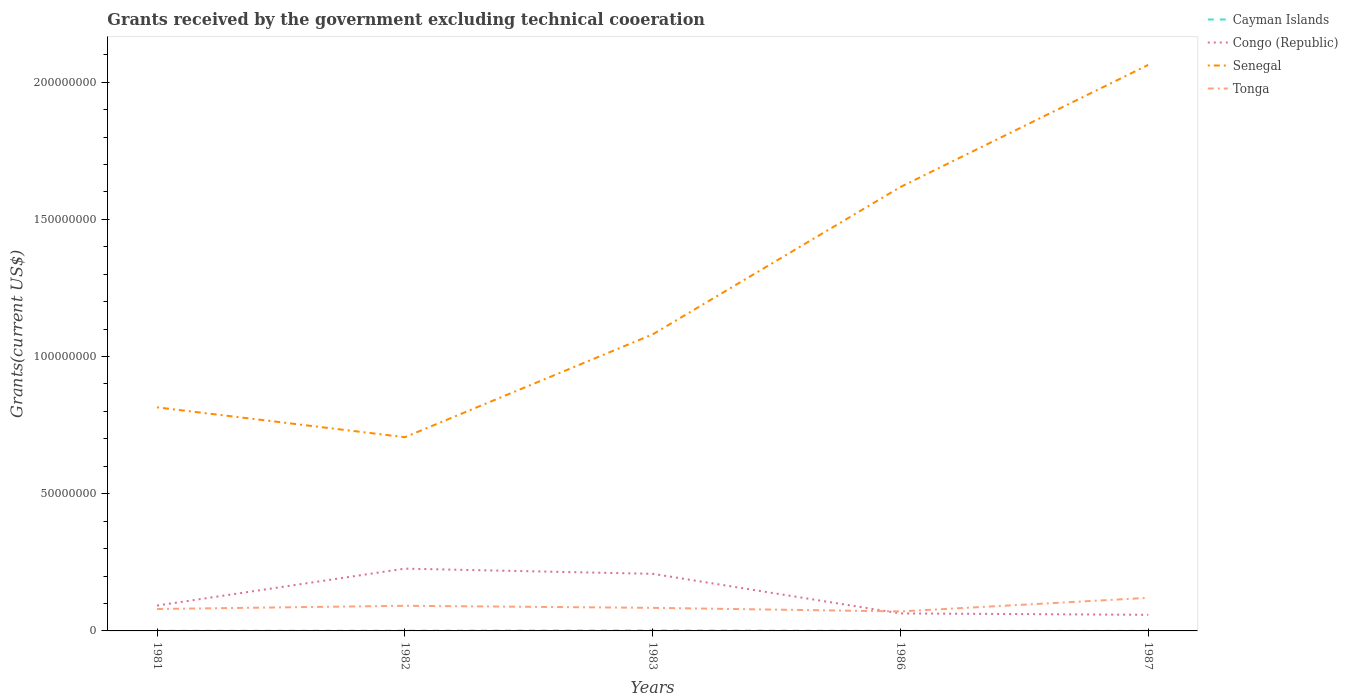How many different coloured lines are there?
Provide a short and direct response. 4. Does the line corresponding to Senegal intersect with the line corresponding to Congo (Republic)?
Offer a terse response. No. Across all years, what is the maximum total grants received by the government in Senegal?
Your answer should be compact. 7.06e+07. What is the total total grants received by the government in Cayman Islands in the graph?
Your response must be concise. 10000. What is the difference between the highest and the second highest total grants received by the government in Tonga?
Your answer should be very brief. 4.96e+06. How many lines are there?
Offer a very short reply. 4. How many years are there in the graph?
Ensure brevity in your answer.  5. What is the difference between two consecutive major ticks on the Y-axis?
Your response must be concise. 5.00e+07. Does the graph contain any zero values?
Keep it short and to the point. No. Does the graph contain grids?
Offer a very short reply. No. Where does the legend appear in the graph?
Provide a succinct answer. Top right. What is the title of the graph?
Give a very brief answer. Grants received by the government excluding technical cooeration. Does "Myanmar" appear as one of the legend labels in the graph?
Offer a terse response. No. What is the label or title of the Y-axis?
Keep it short and to the point. Grants(current US$). What is the Grants(current US$) of Cayman Islands in 1981?
Ensure brevity in your answer.  4.00e+04. What is the Grants(current US$) in Congo (Republic) in 1981?
Provide a succinct answer. 9.25e+06. What is the Grants(current US$) in Senegal in 1981?
Provide a short and direct response. 8.15e+07. What is the Grants(current US$) of Tonga in 1981?
Make the answer very short. 7.99e+06. What is the Grants(current US$) in Cayman Islands in 1982?
Offer a very short reply. 8.00e+04. What is the Grants(current US$) of Congo (Republic) in 1982?
Offer a very short reply. 2.27e+07. What is the Grants(current US$) in Senegal in 1982?
Provide a succinct answer. 7.06e+07. What is the Grants(current US$) of Tonga in 1982?
Ensure brevity in your answer.  9.16e+06. What is the Grants(current US$) in Cayman Islands in 1983?
Make the answer very short. 1.50e+05. What is the Grants(current US$) in Congo (Republic) in 1983?
Give a very brief answer. 2.08e+07. What is the Grants(current US$) of Senegal in 1983?
Your response must be concise. 1.08e+08. What is the Grants(current US$) in Tonga in 1983?
Give a very brief answer. 8.41e+06. What is the Grants(current US$) in Congo (Republic) in 1986?
Ensure brevity in your answer.  6.38e+06. What is the Grants(current US$) in Senegal in 1986?
Offer a terse response. 1.62e+08. What is the Grants(current US$) of Tonga in 1986?
Provide a short and direct response. 7.10e+06. What is the Grants(current US$) in Cayman Islands in 1987?
Your response must be concise. 3.00e+04. What is the Grants(current US$) in Congo (Republic) in 1987?
Ensure brevity in your answer.  5.87e+06. What is the Grants(current US$) in Senegal in 1987?
Provide a short and direct response. 2.06e+08. What is the Grants(current US$) in Tonga in 1987?
Your response must be concise. 1.21e+07. Across all years, what is the maximum Grants(current US$) in Congo (Republic)?
Offer a very short reply. 2.27e+07. Across all years, what is the maximum Grants(current US$) in Senegal?
Your answer should be very brief. 2.06e+08. Across all years, what is the maximum Grants(current US$) in Tonga?
Your answer should be very brief. 1.21e+07. Across all years, what is the minimum Grants(current US$) in Cayman Islands?
Your answer should be compact. 3.00e+04. Across all years, what is the minimum Grants(current US$) of Congo (Republic)?
Keep it short and to the point. 5.87e+06. Across all years, what is the minimum Grants(current US$) in Senegal?
Your answer should be compact. 7.06e+07. Across all years, what is the minimum Grants(current US$) of Tonga?
Provide a succinct answer. 7.10e+06. What is the total Grants(current US$) of Congo (Republic) in the graph?
Make the answer very short. 6.50e+07. What is the total Grants(current US$) of Senegal in the graph?
Provide a short and direct response. 6.28e+08. What is the total Grants(current US$) of Tonga in the graph?
Your response must be concise. 4.47e+07. What is the difference between the Grants(current US$) of Congo (Republic) in 1981 and that in 1982?
Your response must be concise. -1.34e+07. What is the difference between the Grants(current US$) in Senegal in 1981 and that in 1982?
Your answer should be very brief. 1.09e+07. What is the difference between the Grants(current US$) in Tonga in 1981 and that in 1982?
Your answer should be very brief. -1.17e+06. What is the difference between the Grants(current US$) of Congo (Republic) in 1981 and that in 1983?
Make the answer very short. -1.16e+07. What is the difference between the Grants(current US$) of Senegal in 1981 and that in 1983?
Provide a succinct answer. -2.66e+07. What is the difference between the Grants(current US$) in Tonga in 1981 and that in 1983?
Your answer should be compact. -4.20e+05. What is the difference between the Grants(current US$) of Cayman Islands in 1981 and that in 1986?
Your answer should be very brief. 10000. What is the difference between the Grants(current US$) of Congo (Republic) in 1981 and that in 1986?
Offer a terse response. 2.87e+06. What is the difference between the Grants(current US$) in Senegal in 1981 and that in 1986?
Make the answer very short. -8.03e+07. What is the difference between the Grants(current US$) of Tonga in 1981 and that in 1986?
Offer a very short reply. 8.90e+05. What is the difference between the Grants(current US$) of Congo (Republic) in 1981 and that in 1987?
Your answer should be very brief. 3.38e+06. What is the difference between the Grants(current US$) of Senegal in 1981 and that in 1987?
Provide a short and direct response. -1.25e+08. What is the difference between the Grants(current US$) of Tonga in 1981 and that in 1987?
Provide a short and direct response. -4.07e+06. What is the difference between the Grants(current US$) in Cayman Islands in 1982 and that in 1983?
Offer a terse response. -7.00e+04. What is the difference between the Grants(current US$) in Congo (Republic) in 1982 and that in 1983?
Provide a short and direct response. 1.89e+06. What is the difference between the Grants(current US$) in Senegal in 1982 and that in 1983?
Your answer should be compact. -3.75e+07. What is the difference between the Grants(current US$) in Tonga in 1982 and that in 1983?
Ensure brevity in your answer.  7.50e+05. What is the difference between the Grants(current US$) in Congo (Republic) in 1982 and that in 1986?
Make the answer very short. 1.63e+07. What is the difference between the Grants(current US$) of Senegal in 1982 and that in 1986?
Provide a short and direct response. -9.12e+07. What is the difference between the Grants(current US$) of Tonga in 1982 and that in 1986?
Provide a succinct answer. 2.06e+06. What is the difference between the Grants(current US$) in Cayman Islands in 1982 and that in 1987?
Provide a succinct answer. 5.00e+04. What is the difference between the Grants(current US$) in Congo (Republic) in 1982 and that in 1987?
Offer a very short reply. 1.68e+07. What is the difference between the Grants(current US$) of Senegal in 1982 and that in 1987?
Provide a succinct answer. -1.36e+08. What is the difference between the Grants(current US$) in Tonga in 1982 and that in 1987?
Your answer should be very brief. -2.90e+06. What is the difference between the Grants(current US$) in Congo (Republic) in 1983 and that in 1986?
Offer a terse response. 1.44e+07. What is the difference between the Grants(current US$) in Senegal in 1983 and that in 1986?
Keep it short and to the point. -5.37e+07. What is the difference between the Grants(current US$) of Tonga in 1983 and that in 1986?
Keep it short and to the point. 1.31e+06. What is the difference between the Grants(current US$) of Cayman Islands in 1983 and that in 1987?
Your response must be concise. 1.20e+05. What is the difference between the Grants(current US$) of Congo (Republic) in 1983 and that in 1987?
Make the answer very short. 1.49e+07. What is the difference between the Grants(current US$) in Senegal in 1983 and that in 1987?
Your response must be concise. -9.82e+07. What is the difference between the Grants(current US$) in Tonga in 1983 and that in 1987?
Provide a short and direct response. -3.65e+06. What is the difference between the Grants(current US$) of Cayman Islands in 1986 and that in 1987?
Offer a very short reply. 0. What is the difference between the Grants(current US$) of Congo (Republic) in 1986 and that in 1987?
Offer a very short reply. 5.10e+05. What is the difference between the Grants(current US$) in Senegal in 1986 and that in 1987?
Your response must be concise. -4.45e+07. What is the difference between the Grants(current US$) in Tonga in 1986 and that in 1987?
Offer a terse response. -4.96e+06. What is the difference between the Grants(current US$) in Cayman Islands in 1981 and the Grants(current US$) in Congo (Republic) in 1982?
Provide a succinct answer. -2.27e+07. What is the difference between the Grants(current US$) in Cayman Islands in 1981 and the Grants(current US$) in Senegal in 1982?
Offer a terse response. -7.06e+07. What is the difference between the Grants(current US$) in Cayman Islands in 1981 and the Grants(current US$) in Tonga in 1982?
Offer a very short reply. -9.12e+06. What is the difference between the Grants(current US$) in Congo (Republic) in 1981 and the Grants(current US$) in Senegal in 1982?
Give a very brief answer. -6.14e+07. What is the difference between the Grants(current US$) of Senegal in 1981 and the Grants(current US$) of Tonga in 1982?
Your answer should be very brief. 7.23e+07. What is the difference between the Grants(current US$) in Cayman Islands in 1981 and the Grants(current US$) in Congo (Republic) in 1983?
Offer a very short reply. -2.08e+07. What is the difference between the Grants(current US$) of Cayman Islands in 1981 and the Grants(current US$) of Senegal in 1983?
Offer a terse response. -1.08e+08. What is the difference between the Grants(current US$) in Cayman Islands in 1981 and the Grants(current US$) in Tonga in 1983?
Offer a terse response. -8.37e+06. What is the difference between the Grants(current US$) in Congo (Republic) in 1981 and the Grants(current US$) in Senegal in 1983?
Ensure brevity in your answer.  -9.88e+07. What is the difference between the Grants(current US$) in Congo (Republic) in 1981 and the Grants(current US$) in Tonga in 1983?
Keep it short and to the point. 8.40e+05. What is the difference between the Grants(current US$) of Senegal in 1981 and the Grants(current US$) of Tonga in 1983?
Your answer should be compact. 7.31e+07. What is the difference between the Grants(current US$) in Cayman Islands in 1981 and the Grants(current US$) in Congo (Republic) in 1986?
Your response must be concise. -6.34e+06. What is the difference between the Grants(current US$) in Cayman Islands in 1981 and the Grants(current US$) in Senegal in 1986?
Provide a succinct answer. -1.62e+08. What is the difference between the Grants(current US$) in Cayman Islands in 1981 and the Grants(current US$) in Tonga in 1986?
Your answer should be very brief. -7.06e+06. What is the difference between the Grants(current US$) in Congo (Republic) in 1981 and the Grants(current US$) in Senegal in 1986?
Ensure brevity in your answer.  -1.53e+08. What is the difference between the Grants(current US$) of Congo (Republic) in 1981 and the Grants(current US$) of Tonga in 1986?
Give a very brief answer. 2.15e+06. What is the difference between the Grants(current US$) of Senegal in 1981 and the Grants(current US$) of Tonga in 1986?
Make the answer very short. 7.44e+07. What is the difference between the Grants(current US$) in Cayman Islands in 1981 and the Grants(current US$) in Congo (Republic) in 1987?
Keep it short and to the point. -5.83e+06. What is the difference between the Grants(current US$) of Cayman Islands in 1981 and the Grants(current US$) of Senegal in 1987?
Ensure brevity in your answer.  -2.06e+08. What is the difference between the Grants(current US$) of Cayman Islands in 1981 and the Grants(current US$) of Tonga in 1987?
Make the answer very short. -1.20e+07. What is the difference between the Grants(current US$) of Congo (Republic) in 1981 and the Grants(current US$) of Senegal in 1987?
Your answer should be very brief. -1.97e+08. What is the difference between the Grants(current US$) of Congo (Republic) in 1981 and the Grants(current US$) of Tonga in 1987?
Keep it short and to the point. -2.81e+06. What is the difference between the Grants(current US$) in Senegal in 1981 and the Grants(current US$) in Tonga in 1987?
Your answer should be very brief. 6.94e+07. What is the difference between the Grants(current US$) of Cayman Islands in 1982 and the Grants(current US$) of Congo (Republic) in 1983?
Offer a very short reply. -2.07e+07. What is the difference between the Grants(current US$) in Cayman Islands in 1982 and the Grants(current US$) in Senegal in 1983?
Ensure brevity in your answer.  -1.08e+08. What is the difference between the Grants(current US$) of Cayman Islands in 1982 and the Grants(current US$) of Tonga in 1983?
Make the answer very short. -8.33e+06. What is the difference between the Grants(current US$) of Congo (Republic) in 1982 and the Grants(current US$) of Senegal in 1983?
Your answer should be compact. -8.54e+07. What is the difference between the Grants(current US$) of Congo (Republic) in 1982 and the Grants(current US$) of Tonga in 1983?
Offer a terse response. 1.43e+07. What is the difference between the Grants(current US$) of Senegal in 1982 and the Grants(current US$) of Tonga in 1983?
Ensure brevity in your answer.  6.22e+07. What is the difference between the Grants(current US$) in Cayman Islands in 1982 and the Grants(current US$) in Congo (Republic) in 1986?
Offer a very short reply. -6.30e+06. What is the difference between the Grants(current US$) of Cayman Islands in 1982 and the Grants(current US$) of Senegal in 1986?
Your answer should be very brief. -1.62e+08. What is the difference between the Grants(current US$) of Cayman Islands in 1982 and the Grants(current US$) of Tonga in 1986?
Provide a short and direct response. -7.02e+06. What is the difference between the Grants(current US$) in Congo (Republic) in 1982 and the Grants(current US$) in Senegal in 1986?
Make the answer very short. -1.39e+08. What is the difference between the Grants(current US$) in Congo (Republic) in 1982 and the Grants(current US$) in Tonga in 1986?
Ensure brevity in your answer.  1.56e+07. What is the difference between the Grants(current US$) in Senegal in 1982 and the Grants(current US$) in Tonga in 1986?
Ensure brevity in your answer.  6.35e+07. What is the difference between the Grants(current US$) in Cayman Islands in 1982 and the Grants(current US$) in Congo (Republic) in 1987?
Provide a succinct answer. -5.79e+06. What is the difference between the Grants(current US$) in Cayman Islands in 1982 and the Grants(current US$) in Senegal in 1987?
Provide a succinct answer. -2.06e+08. What is the difference between the Grants(current US$) in Cayman Islands in 1982 and the Grants(current US$) in Tonga in 1987?
Your answer should be compact. -1.20e+07. What is the difference between the Grants(current US$) of Congo (Republic) in 1982 and the Grants(current US$) of Senegal in 1987?
Offer a terse response. -1.84e+08. What is the difference between the Grants(current US$) of Congo (Republic) in 1982 and the Grants(current US$) of Tonga in 1987?
Your answer should be very brief. 1.06e+07. What is the difference between the Grants(current US$) of Senegal in 1982 and the Grants(current US$) of Tonga in 1987?
Your answer should be compact. 5.85e+07. What is the difference between the Grants(current US$) of Cayman Islands in 1983 and the Grants(current US$) of Congo (Republic) in 1986?
Your answer should be compact. -6.23e+06. What is the difference between the Grants(current US$) of Cayman Islands in 1983 and the Grants(current US$) of Senegal in 1986?
Your answer should be compact. -1.62e+08. What is the difference between the Grants(current US$) of Cayman Islands in 1983 and the Grants(current US$) of Tonga in 1986?
Offer a very short reply. -6.95e+06. What is the difference between the Grants(current US$) in Congo (Republic) in 1983 and the Grants(current US$) in Senegal in 1986?
Make the answer very short. -1.41e+08. What is the difference between the Grants(current US$) of Congo (Republic) in 1983 and the Grants(current US$) of Tonga in 1986?
Your answer should be very brief. 1.37e+07. What is the difference between the Grants(current US$) of Senegal in 1983 and the Grants(current US$) of Tonga in 1986?
Provide a succinct answer. 1.01e+08. What is the difference between the Grants(current US$) of Cayman Islands in 1983 and the Grants(current US$) of Congo (Republic) in 1987?
Give a very brief answer. -5.72e+06. What is the difference between the Grants(current US$) of Cayman Islands in 1983 and the Grants(current US$) of Senegal in 1987?
Make the answer very short. -2.06e+08. What is the difference between the Grants(current US$) in Cayman Islands in 1983 and the Grants(current US$) in Tonga in 1987?
Your answer should be very brief. -1.19e+07. What is the difference between the Grants(current US$) in Congo (Republic) in 1983 and the Grants(current US$) in Senegal in 1987?
Offer a terse response. -1.85e+08. What is the difference between the Grants(current US$) of Congo (Republic) in 1983 and the Grants(current US$) of Tonga in 1987?
Your answer should be compact. 8.75e+06. What is the difference between the Grants(current US$) in Senegal in 1983 and the Grants(current US$) in Tonga in 1987?
Your answer should be compact. 9.60e+07. What is the difference between the Grants(current US$) in Cayman Islands in 1986 and the Grants(current US$) in Congo (Republic) in 1987?
Your answer should be compact. -5.84e+06. What is the difference between the Grants(current US$) of Cayman Islands in 1986 and the Grants(current US$) of Senegal in 1987?
Offer a terse response. -2.06e+08. What is the difference between the Grants(current US$) in Cayman Islands in 1986 and the Grants(current US$) in Tonga in 1987?
Ensure brevity in your answer.  -1.20e+07. What is the difference between the Grants(current US$) of Congo (Republic) in 1986 and the Grants(current US$) of Senegal in 1987?
Offer a terse response. -2.00e+08. What is the difference between the Grants(current US$) in Congo (Republic) in 1986 and the Grants(current US$) in Tonga in 1987?
Provide a succinct answer. -5.68e+06. What is the difference between the Grants(current US$) in Senegal in 1986 and the Grants(current US$) in Tonga in 1987?
Your answer should be very brief. 1.50e+08. What is the average Grants(current US$) in Cayman Islands per year?
Make the answer very short. 6.60e+04. What is the average Grants(current US$) of Congo (Republic) per year?
Keep it short and to the point. 1.30e+07. What is the average Grants(current US$) in Senegal per year?
Keep it short and to the point. 1.26e+08. What is the average Grants(current US$) in Tonga per year?
Offer a terse response. 8.94e+06. In the year 1981, what is the difference between the Grants(current US$) in Cayman Islands and Grants(current US$) in Congo (Republic)?
Provide a short and direct response. -9.21e+06. In the year 1981, what is the difference between the Grants(current US$) in Cayman Islands and Grants(current US$) in Senegal?
Provide a succinct answer. -8.14e+07. In the year 1981, what is the difference between the Grants(current US$) of Cayman Islands and Grants(current US$) of Tonga?
Provide a short and direct response. -7.95e+06. In the year 1981, what is the difference between the Grants(current US$) in Congo (Republic) and Grants(current US$) in Senegal?
Keep it short and to the point. -7.22e+07. In the year 1981, what is the difference between the Grants(current US$) in Congo (Republic) and Grants(current US$) in Tonga?
Keep it short and to the point. 1.26e+06. In the year 1981, what is the difference between the Grants(current US$) in Senegal and Grants(current US$) in Tonga?
Provide a short and direct response. 7.35e+07. In the year 1982, what is the difference between the Grants(current US$) of Cayman Islands and Grants(current US$) of Congo (Republic)?
Your answer should be very brief. -2.26e+07. In the year 1982, what is the difference between the Grants(current US$) in Cayman Islands and Grants(current US$) in Senegal?
Give a very brief answer. -7.05e+07. In the year 1982, what is the difference between the Grants(current US$) in Cayman Islands and Grants(current US$) in Tonga?
Offer a very short reply. -9.08e+06. In the year 1982, what is the difference between the Grants(current US$) in Congo (Republic) and Grants(current US$) in Senegal?
Your response must be concise. -4.79e+07. In the year 1982, what is the difference between the Grants(current US$) in Congo (Republic) and Grants(current US$) in Tonga?
Ensure brevity in your answer.  1.35e+07. In the year 1982, what is the difference between the Grants(current US$) in Senegal and Grants(current US$) in Tonga?
Offer a very short reply. 6.14e+07. In the year 1983, what is the difference between the Grants(current US$) in Cayman Islands and Grants(current US$) in Congo (Republic)?
Ensure brevity in your answer.  -2.07e+07. In the year 1983, what is the difference between the Grants(current US$) in Cayman Islands and Grants(current US$) in Senegal?
Provide a short and direct response. -1.08e+08. In the year 1983, what is the difference between the Grants(current US$) of Cayman Islands and Grants(current US$) of Tonga?
Provide a short and direct response. -8.26e+06. In the year 1983, what is the difference between the Grants(current US$) of Congo (Republic) and Grants(current US$) of Senegal?
Provide a succinct answer. -8.73e+07. In the year 1983, what is the difference between the Grants(current US$) of Congo (Republic) and Grants(current US$) of Tonga?
Offer a terse response. 1.24e+07. In the year 1983, what is the difference between the Grants(current US$) of Senegal and Grants(current US$) of Tonga?
Your answer should be very brief. 9.97e+07. In the year 1986, what is the difference between the Grants(current US$) of Cayman Islands and Grants(current US$) of Congo (Republic)?
Make the answer very short. -6.35e+06. In the year 1986, what is the difference between the Grants(current US$) of Cayman Islands and Grants(current US$) of Senegal?
Provide a succinct answer. -1.62e+08. In the year 1986, what is the difference between the Grants(current US$) in Cayman Islands and Grants(current US$) in Tonga?
Keep it short and to the point. -7.07e+06. In the year 1986, what is the difference between the Grants(current US$) in Congo (Republic) and Grants(current US$) in Senegal?
Your response must be concise. -1.55e+08. In the year 1986, what is the difference between the Grants(current US$) in Congo (Republic) and Grants(current US$) in Tonga?
Offer a terse response. -7.20e+05. In the year 1986, what is the difference between the Grants(current US$) of Senegal and Grants(current US$) of Tonga?
Your answer should be very brief. 1.55e+08. In the year 1987, what is the difference between the Grants(current US$) of Cayman Islands and Grants(current US$) of Congo (Republic)?
Offer a terse response. -5.84e+06. In the year 1987, what is the difference between the Grants(current US$) of Cayman Islands and Grants(current US$) of Senegal?
Ensure brevity in your answer.  -2.06e+08. In the year 1987, what is the difference between the Grants(current US$) in Cayman Islands and Grants(current US$) in Tonga?
Your answer should be very brief. -1.20e+07. In the year 1987, what is the difference between the Grants(current US$) of Congo (Republic) and Grants(current US$) of Senegal?
Provide a succinct answer. -2.00e+08. In the year 1987, what is the difference between the Grants(current US$) in Congo (Republic) and Grants(current US$) in Tonga?
Make the answer very short. -6.19e+06. In the year 1987, what is the difference between the Grants(current US$) of Senegal and Grants(current US$) of Tonga?
Your response must be concise. 1.94e+08. What is the ratio of the Grants(current US$) of Congo (Republic) in 1981 to that in 1982?
Make the answer very short. 0.41. What is the ratio of the Grants(current US$) of Senegal in 1981 to that in 1982?
Make the answer very short. 1.15. What is the ratio of the Grants(current US$) of Tonga in 1981 to that in 1982?
Your response must be concise. 0.87. What is the ratio of the Grants(current US$) in Cayman Islands in 1981 to that in 1983?
Offer a terse response. 0.27. What is the ratio of the Grants(current US$) of Congo (Republic) in 1981 to that in 1983?
Your response must be concise. 0.44. What is the ratio of the Grants(current US$) in Senegal in 1981 to that in 1983?
Provide a short and direct response. 0.75. What is the ratio of the Grants(current US$) of Tonga in 1981 to that in 1983?
Provide a succinct answer. 0.95. What is the ratio of the Grants(current US$) of Congo (Republic) in 1981 to that in 1986?
Provide a short and direct response. 1.45. What is the ratio of the Grants(current US$) in Senegal in 1981 to that in 1986?
Offer a terse response. 0.5. What is the ratio of the Grants(current US$) in Tonga in 1981 to that in 1986?
Give a very brief answer. 1.13. What is the ratio of the Grants(current US$) in Congo (Republic) in 1981 to that in 1987?
Keep it short and to the point. 1.58. What is the ratio of the Grants(current US$) in Senegal in 1981 to that in 1987?
Your answer should be very brief. 0.4. What is the ratio of the Grants(current US$) in Tonga in 1981 to that in 1987?
Give a very brief answer. 0.66. What is the ratio of the Grants(current US$) in Cayman Islands in 1982 to that in 1983?
Keep it short and to the point. 0.53. What is the ratio of the Grants(current US$) in Congo (Republic) in 1982 to that in 1983?
Ensure brevity in your answer.  1.09. What is the ratio of the Grants(current US$) in Senegal in 1982 to that in 1983?
Keep it short and to the point. 0.65. What is the ratio of the Grants(current US$) of Tonga in 1982 to that in 1983?
Provide a short and direct response. 1.09. What is the ratio of the Grants(current US$) of Cayman Islands in 1982 to that in 1986?
Provide a short and direct response. 2.67. What is the ratio of the Grants(current US$) in Congo (Republic) in 1982 to that in 1986?
Provide a short and direct response. 3.56. What is the ratio of the Grants(current US$) of Senegal in 1982 to that in 1986?
Provide a short and direct response. 0.44. What is the ratio of the Grants(current US$) in Tonga in 1982 to that in 1986?
Make the answer very short. 1.29. What is the ratio of the Grants(current US$) in Cayman Islands in 1982 to that in 1987?
Your answer should be very brief. 2.67. What is the ratio of the Grants(current US$) in Congo (Republic) in 1982 to that in 1987?
Make the answer very short. 3.87. What is the ratio of the Grants(current US$) in Senegal in 1982 to that in 1987?
Make the answer very short. 0.34. What is the ratio of the Grants(current US$) of Tonga in 1982 to that in 1987?
Ensure brevity in your answer.  0.76. What is the ratio of the Grants(current US$) in Congo (Republic) in 1983 to that in 1986?
Provide a short and direct response. 3.26. What is the ratio of the Grants(current US$) of Senegal in 1983 to that in 1986?
Offer a terse response. 0.67. What is the ratio of the Grants(current US$) in Tonga in 1983 to that in 1986?
Your response must be concise. 1.18. What is the ratio of the Grants(current US$) in Congo (Republic) in 1983 to that in 1987?
Give a very brief answer. 3.55. What is the ratio of the Grants(current US$) in Senegal in 1983 to that in 1987?
Keep it short and to the point. 0.52. What is the ratio of the Grants(current US$) in Tonga in 1983 to that in 1987?
Provide a succinct answer. 0.7. What is the ratio of the Grants(current US$) in Congo (Republic) in 1986 to that in 1987?
Provide a succinct answer. 1.09. What is the ratio of the Grants(current US$) of Senegal in 1986 to that in 1987?
Your answer should be compact. 0.78. What is the ratio of the Grants(current US$) of Tonga in 1986 to that in 1987?
Your answer should be compact. 0.59. What is the difference between the highest and the second highest Grants(current US$) in Congo (Republic)?
Your answer should be compact. 1.89e+06. What is the difference between the highest and the second highest Grants(current US$) of Senegal?
Your response must be concise. 4.45e+07. What is the difference between the highest and the second highest Grants(current US$) in Tonga?
Your answer should be compact. 2.90e+06. What is the difference between the highest and the lowest Grants(current US$) in Cayman Islands?
Your answer should be very brief. 1.20e+05. What is the difference between the highest and the lowest Grants(current US$) in Congo (Republic)?
Give a very brief answer. 1.68e+07. What is the difference between the highest and the lowest Grants(current US$) in Senegal?
Give a very brief answer. 1.36e+08. What is the difference between the highest and the lowest Grants(current US$) of Tonga?
Give a very brief answer. 4.96e+06. 